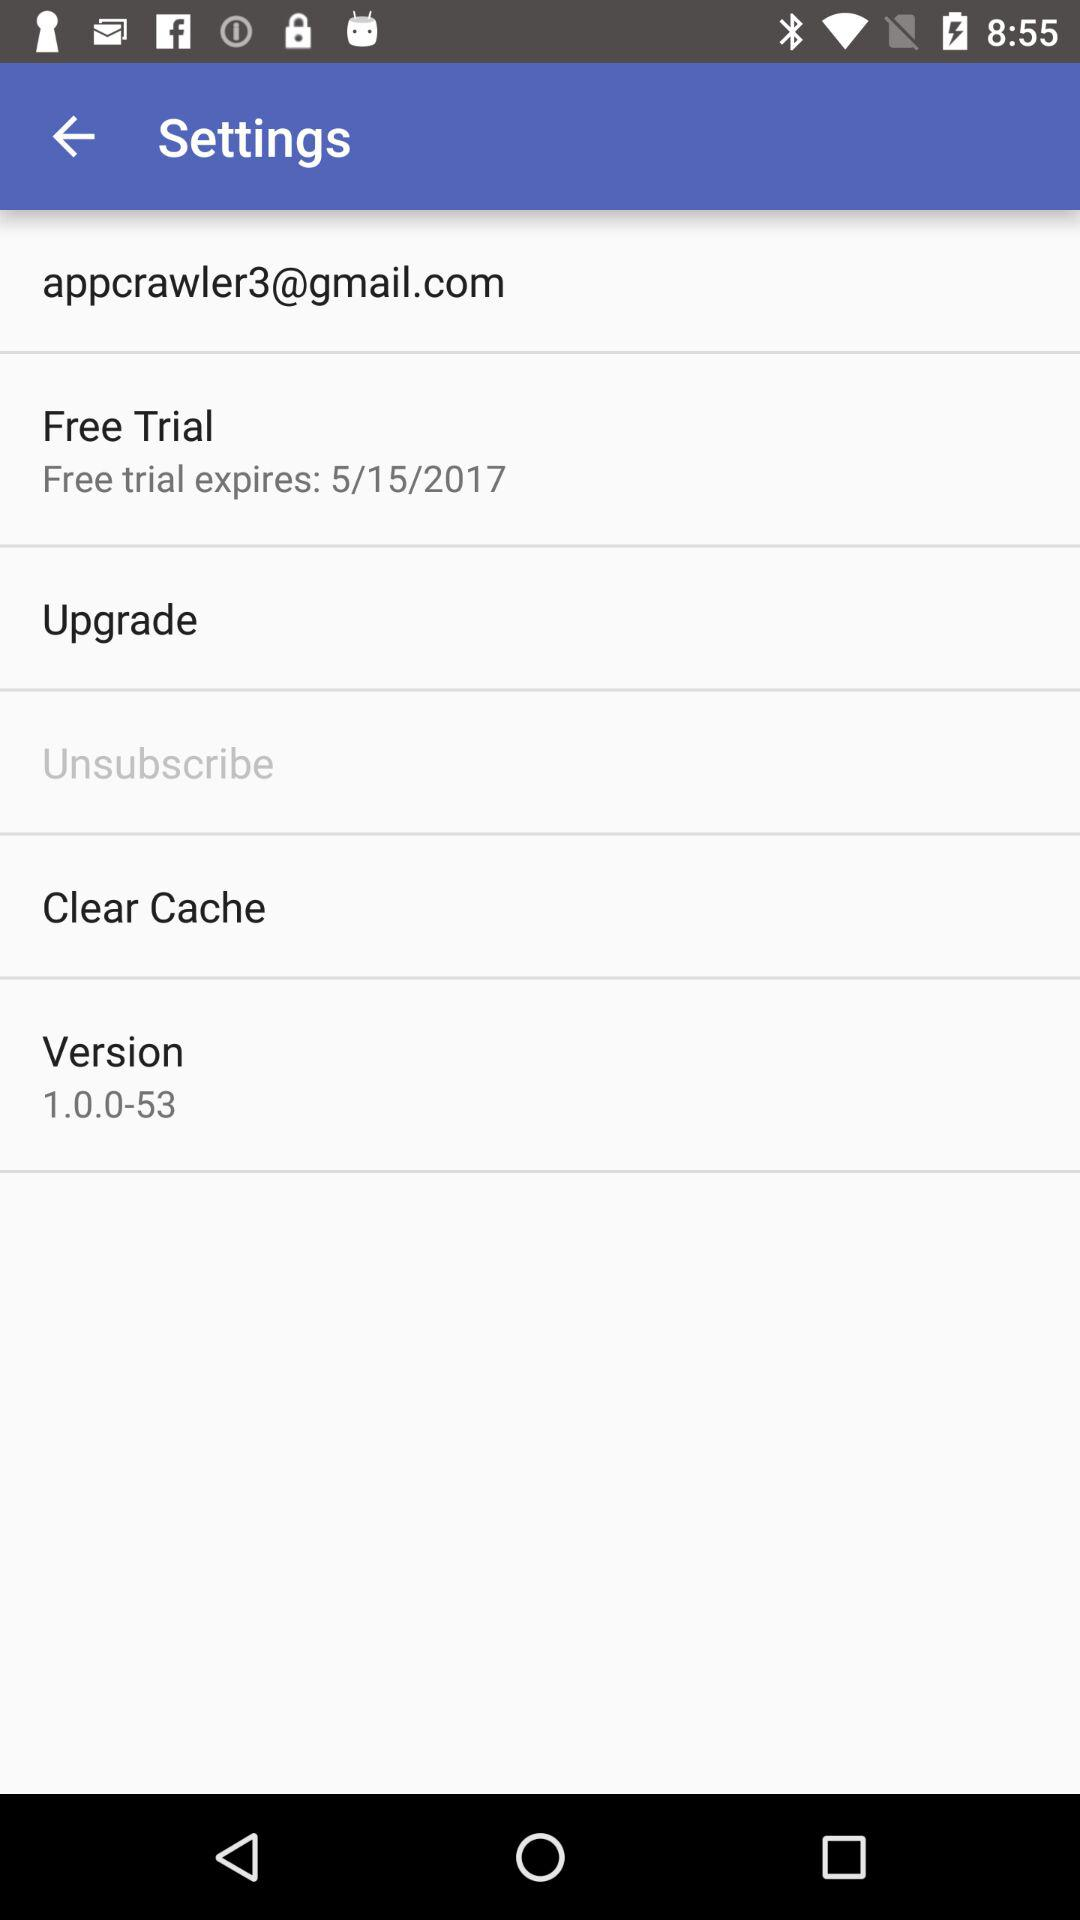Has the cache been cleared?
When the provided information is insufficient, respond with <no answer>. <no answer> 